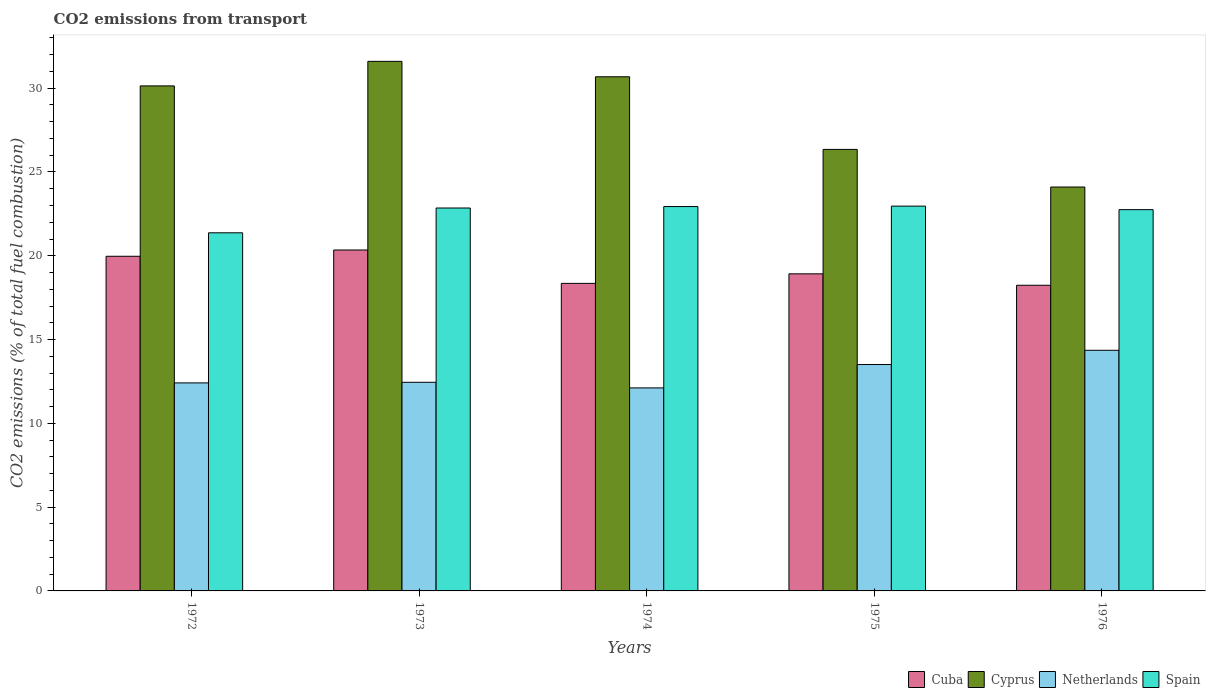How many different coloured bars are there?
Your answer should be compact. 4. Are the number of bars per tick equal to the number of legend labels?
Keep it short and to the point. Yes. How many bars are there on the 4th tick from the left?
Give a very brief answer. 4. How many bars are there on the 2nd tick from the right?
Your response must be concise. 4. What is the label of the 1st group of bars from the left?
Your answer should be very brief. 1972. In how many cases, is the number of bars for a given year not equal to the number of legend labels?
Provide a short and direct response. 0. What is the total CO2 emitted in Netherlands in 1976?
Your answer should be very brief. 14.36. Across all years, what is the maximum total CO2 emitted in Spain?
Make the answer very short. 22.96. Across all years, what is the minimum total CO2 emitted in Cuba?
Ensure brevity in your answer.  18.24. In which year was the total CO2 emitted in Spain maximum?
Provide a succinct answer. 1975. In which year was the total CO2 emitted in Spain minimum?
Your response must be concise. 1972. What is the total total CO2 emitted in Netherlands in the graph?
Ensure brevity in your answer.  64.85. What is the difference between the total CO2 emitted in Netherlands in 1972 and that in 1973?
Keep it short and to the point. -0.04. What is the difference between the total CO2 emitted in Cuba in 1973 and the total CO2 emitted in Spain in 1974?
Ensure brevity in your answer.  -2.59. What is the average total CO2 emitted in Cyprus per year?
Give a very brief answer. 28.57. In the year 1975, what is the difference between the total CO2 emitted in Cuba and total CO2 emitted in Cyprus?
Give a very brief answer. -7.42. What is the ratio of the total CO2 emitted in Netherlands in 1973 to that in 1974?
Offer a very short reply. 1.03. Is the difference between the total CO2 emitted in Cuba in 1973 and 1975 greater than the difference between the total CO2 emitted in Cyprus in 1973 and 1975?
Provide a short and direct response. No. What is the difference between the highest and the second highest total CO2 emitted in Netherlands?
Ensure brevity in your answer.  0.85. What is the difference between the highest and the lowest total CO2 emitted in Cyprus?
Make the answer very short. 7.5. Is it the case that in every year, the sum of the total CO2 emitted in Spain and total CO2 emitted in Cuba is greater than the sum of total CO2 emitted in Cyprus and total CO2 emitted in Netherlands?
Your answer should be very brief. No. What does the 1st bar from the right in 1975 represents?
Provide a succinct answer. Spain. Are all the bars in the graph horizontal?
Give a very brief answer. No. Does the graph contain any zero values?
Keep it short and to the point. No. Where does the legend appear in the graph?
Provide a succinct answer. Bottom right. What is the title of the graph?
Give a very brief answer. CO2 emissions from transport. Does "Philippines" appear as one of the legend labels in the graph?
Your response must be concise. No. What is the label or title of the X-axis?
Offer a very short reply. Years. What is the label or title of the Y-axis?
Offer a very short reply. CO2 emissions (% of total fuel combustion). What is the CO2 emissions (% of total fuel combustion) in Cuba in 1972?
Your response must be concise. 19.97. What is the CO2 emissions (% of total fuel combustion) of Cyprus in 1972?
Give a very brief answer. 30.14. What is the CO2 emissions (% of total fuel combustion) in Netherlands in 1972?
Provide a short and direct response. 12.41. What is the CO2 emissions (% of total fuel combustion) of Spain in 1972?
Offer a very short reply. 21.37. What is the CO2 emissions (% of total fuel combustion) in Cuba in 1973?
Offer a terse response. 20.34. What is the CO2 emissions (% of total fuel combustion) of Cyprus in 1973?
Keep it short and to the point. 31.6. What is the CO2 emissions (% of total fuel combustion) of Netherlands in 1973?
Offer a very short reply. 12.45. What is the CO2 emissions (% of total fuel combustion) of Spain in 1973?
Offer a very short reply. 22.85. What is the CO2 emissions (% of total fuel combustion) in Cuba in 1974?
Offer a terse response. 18.35. What is the CO2 emissions (% of total fuel combustion) in Cyprus in 1974?
Ensure brevity in your answer.  30.68. What is the CO2 emissions (% of total fuel combustion) of Netherlands in 1974?
Provide a succinct answer. 12.12. What is the CO2 emissions (% of total fuel combustion) of Spain in 1974?
Offer a very short reply. 22.94. What is the CO2 emissions (% of total fuel combustion) of Cuba in 1975?
Offer a terse response. 18.92. What is the CO2 emissions (% of total fuel combustion) of Cyprus in 1975?
Offer a terse response. 26.35. What is the CO2 emissions (% of total fuel combustion) of Netherlands in 1975?
Keep it short and to the point. 13.51. What is the CO2 emissions (% of total fuel combustion) in Spain in 1975?
Ensure brevity in your answer.  22.96. What is the CO2 emissions (% of total fuel combustion) in Cuba in 1976?
Provide a short and direct response. 18.24. What is the CO2 emissions (% of total fuel combustion) of Cyprus in 1976?
Provide a succinct answer. 24.1. What is the CO2 emissions (% of total fuel combustion) of Netherlands in 1976?
Give a very brief answer. 14.36. What is the CO2 emissions (% of total fuel combustion) in Spain in 1976?
Offer a terse response. 22.75. Across all years, what is the maximum CO2 emissions (% of total fuel combustion) in Cuba?
Give a very brief answer. 20.34. Across all years, what is the maximum CO2 emissions (% of total fuel combustion) in Cyprus?
Offer a very short reply. 31.6. Across all years, what is the maximum CO2 emissions (% of total fuel combustion) of Netherlands?
Make the answer very short. 14.36. Across all years, what is the maximum CO2 emissions (% of total fuel combustion) in Spain?
Ensure brevity in your answer.  22.96. Across all years, what is the minimum CO2 emissions (% of total fuel combustion) in Cuba?
Give a very brief answer. 18.24. Across all years, what is the minimum CO2 emissions (% of total fuel combustion) of Cyprus?
Offer a very short reply. 24.1. Across all years, what is the minimum CO2 emissions (% of total fuel combustion) in Netherlands?
Make the answer very short. 12.12. Across all years, what is the minimum CO2 emissions (% of total fuel combustion) of Spain?
Your answer should be very brief. 21.37. What is the total CO2 emissions (% of total fuel combustion) in Cuba in the graph?
Give a very brief answer. 95.83. What is the total CO2 emissions (% of total fuel combustion) in Cyprus in the graph?
Offer a terse response. 142.87. What is the total CO2 emissions (% of total fuel combustion) of Netherlands in the graph?
Provide a short and direct response. 64.85. What is the total CO2 emissions (% of total fuel combustion) in Spain in the graph?
Your answer should be very brief. 112.87. What is the difference between the CO2 emissions (% of total fuel combustion) of Cuba in 1972 and that in 1973?
Make the answer very short. -0.37. What is the difference between the CO2 emissions (% of total fuel combustion) of Cyprus in 1972 and that in 1973?
Offer a very short reply. -1.46. What is the difference between the CO2 emissions (% of total fuel combustion) in Netherlands in 1972 and that in 1973?
Provide a short and direct response. -0.04. What is the difference between the CO2 emissions (% of total fuel combustion) in Spain in 1972 and that in 1973?
Give a very brief answer. -1.48. What is the difference between the CO2 emissions (% of total fuel combustion) in Cuba in 1972 and that in 1974?
Provide a succinct answer. 1.62. What is the difference between the CO2 emissions (% of total fuel combustion) of Cyprus in 1972 and that in 1974?
Give a very brief answer. -0.54. What is the difference between the CO2 emissions (% of total fuel combustion) in Netherlands in 1972 and that in 1974?
Provide a succinct answer. 0.3. What is the difference between the CO2 emissions (% of total fuel combustion) in Spain in 1972 and that in 1974?
Your response must be concise. -1.57. What is the difference between the CO2 emissions (% of total fuel combustion) of Cuba in 1972 and that in 1975?
Your answer should be compact. 1.05. What is the difference between the CO2 emissions (% of total fuel combustion) in Cyprus in 1972 and that in 1975?
Keep it short and to the point. 3.79. What is the difference between the CO2 emissions (% of total fuel combustion) in Netherlands in 1972 and that in 1975?
Your answer should be compact. -1.1. What is the difference between the CO2 emissions (% of total fuel combustion) of Spain in 1972 and that in 1975?
Offer a very short reply. -1.59. What is the difference between the CO2 emissions (% of total fuel combustion) of Cuba in 1972 and that in 1976?
Ensure brevity in your answer.  1.73. What is the difference between the CO2 emissions (% of total fuel combustion) in Cyprus in 1972 and that in 1976?
Your answer should be very brief. 6.03. What is the difference between the CO2 emissions (% of total fuel combustion) in Netherlands in 1972 and that in 1976?
Your answer should be compact. -1.95. What is the difference between the CO2 emissions (% of total fuel combustion) of Spain in 1972 and that in 1976?
Make the answer very short. -1.38. What is the difference between the CO2 emissions (% of total fuel combustion) of Cuba in 1973 and that in 1974?
Your answer should be compact. 1.99. What is the difference between the CO2 emissions (% of total fuel combustion) in Cyprus in 1973 and that in 1974?
Offer a terse response. 0.92. What is the difference between the CO2 emissions (% of total fuel combustion) in Netherlands in 1973 and that in 1974?
Give a very brief answer. 0.33. What is the difference between the CO2 emissions (% of total fuel combustion) of Spain in 1973 and that in 1974?
Keep it short and to the point. -0.09. What is the difference between the CO2 emissions (% of total fuel combustion) of Cuba in 1973 and that in 1975?
Make the answer very short. 1.42. What is the difference between the CO2 emissions (% of total fuel combustion) in Cyprus in 1973 and that in 1975?
Offer a terse response. 5.25. What is the difference between the CO2 emissions (% of total fuel combustion) in Netherlands in 1973 and that in 1975?
Offer a terse response. -1.06. What is the difference between the CO2 emissions (% of total fuel combustion) of Spain in 1973 and that in 1975?
Your response must be concise. -0.11. What is the difference between the CO2 emissions (% of total fuel combustion) of Cuba in 1973 and that in 1976?
Offer a terse response. 2.1. What is the difference between the CO2 emissions (% of total fuel combustion) in Cyprus in 1973 and that in 1976?
Offer a very short reply. 7.5. What is the difference between the CO2 emissions (% of total fuel combustion) in Netherlands in 1973 and that in 1976?
Offer a terse response. -1.91. What is the difference between the CO2 emissions (% of total fuel combustion) in Spain in 1973 and that in 1976?
Ensure brevity in your answer.  0.1. What is the difference between the CO2 emissions (% of total fuel combustion) of Cuba in 1974 and that in 1975?
Keep it short and to the point. -0.57. What is the difference between the CO2 emissions (% of total fuel combustion) of Cyprus in 1974 and that in 1975?
Ensure brevity in your answer.  4.33. What is the difference between the CO2 emissions (% of total fuel combustion) of Netherlands in 1974 and that in 1975?
Your answer should be compact. -1.4. What is the difference between the CO2 emissions (% of total fuel combustion) in Spain in 1974 and that in 1975?
Your response must be concise. -0.03. What is the difference between the CO2 emissions (% of total fuel combustion) in Cuba in 1974 and that in 1976?
Provide a short and direct response. 0.11. What is the difference between the CO2 emissions (% of total fuel combustion) of Cyprus in 1974 and that in 1976?
Offer a terse response. 6.58. What is the difference between the CO2 emissions (% of total fuel combustion) in Netherlands in 1974 and that in 1976?
Your answer should be very brief. -2.24. What is the difference between the CO2 emissions (% of total fuel combustion) of Spain in 1974 and that in 1976?
Offer a very short reply. 0.18. What is the difference between the CO2 emissions (% of total fuel combustion) of Cuba in 1975 and that in 1976?
Offer a terse response. 0.68. What is the difference between the CO2 emissions (% of total fuel combustion) in Cyprus in 1975 and that in 1976?
Offer a terse response. 2.24. What is the difference between the CO2 emissions (% of total fuel combustion) in Netherlands in 1975 and that in 1976?
Make the answer very short. -0.85. What is the difference between the CO2 emissions (% of total fuel combustion) of Spain in 1975 and that in 1976?
Keep it short and to the point. 0.21. What is the difference between the CO2 emissions (% of total fuel combustion) of Cuba in 1972 and the CO2 emissions (% of total fuel combustion) of Cyprus in 1973?
Make the answer very short. -11.63. What is the difference between the CO2 emissions (% of total fuel combustion) of Cuba in 1972 and the CO2 emissions (% of total fuel combustion) of Netherlands in 1973?
Provide a succinct answer. 7.52. What is the difference between the CO2 emissions (% of total fuel combustion) of Cuba in 1972 and the CO2 emissions (% of total fuel combustion) of Spain in 1973?
Provide a short and direct response. -2.88. What is the difference between the CO2 emissions (% of total fuel combustion) in Cyprus in 1972 and the CO2 emissions (% of total fuel combustion) in Netherlands in 1973?
Your response must be concise. 17.69. What is the difference between the CO2 emissions (% of total fuel combustion) of Cyprus in 1972 and the CO2 emissions (% of total fuel combustion) of Spain in 1973?
Offer a terse response. 7.29. What is the difference between the CO2 emissions (% of total fuel combustion) of Netherlands in 1972 and the CO2 emissions (% of total fuel combustion) of Spain in 1973?
Offer a very short reply. -10.44. What is the difference between the CO2 emissions (% of total fuel combustion) in Cuba in 1972 and the CO2 emissions (% of total fuel combustion) in Cyprus in 1974?
Provide a succinct answer. -10.71. What is the difference between the CO2 emissions (% of total fuel combustion) in Cuba in 1972 and the CO2 emissions (% of total fuel combustion) in Netherlands in 1974?
Ensure brevity in your answer.  7.85. What is the difference between the CO2 emissions (% of total fuel combustion) in Cuba in 1972 and the CO2 emissions (% of total fuel combustion) in Spain in 1974?
Make the answer very short. -2.97. What is the difference between the CO2 emissions (% of total fuel combustion) in Cyprus in 1972 and the CO2 emissions (% of total fuel combustion) in Netherlands in 1974?
Your answer should be very brief. 18.02. What is the difference between the CO2 emissions (% of total fuel combustion) in Cyprus in 1972 and the CO2 emissions (% of total fuel combustion) in Spain in 1974?
Provide a short and direct response. 7.2. What is the difference between the CO2 emissions (% of total fuel combustion) in Netherlands in 1972 and the CO2 emissions (% of total fuel combustion) in Spain in 1974?
Your answer should be very brief. -10.52. What is the difference between the CO2 emissions (% of total fuel combustion) in Cuba in 1972 and the CO2 emissions (% of total fuel combustion) in Cyprus in 1975?
Your response must be concise. -6.38. What is the difference between the CO2 emissions (% of total fuel combustion) in Cuba in 1972 and the CO2 emissions (% of total fuel combustion) in Netherlands in 1975?
Your answer should be compact. 6.46. What is the difference between the CO2 emissions (% of total fuel combustion) in Cuba in 1972 and the CO2 emissions (% of total fuel combustion) in Spain in 1975?
Your response must be concise. -2.99. What is the difference between the CO2 emissions (% of total fuel combustion) of Cyprus in 1972 and the CO2 emissions (% of total fuel combustion) of Netherlands in 1975?
Offer a very short reply. 16.63. What is the difference between the CO2 emissions (% of total fuel combustion) of Cyprus in 1972 and the CO2 emissions (% of total fuel combustion) of Spain in 1975?
Offer a very short reply. 7.17. What is the difference between the CO2 emissions (% of total fuel combustion) in Netherlands in 1972 and the CO2 emissions (% of total fuel combustion) in Spain in 1975?
Ensure brevity in your answer.  -10.55. What is the difference between the CO2 emissions (% of total fuel combustion) of Cuba in 1972 and the CO2 emissions (% of total fuel combustion) of Cyprus in 1976?
Your answer should be compact. -4.13. What is the difference between the CO2 emissions (% of total fuel combustion) of Cuba in 1972 and the CO2 emissions (% of total fuel combustion) of Netherlands in 1976?
Provide a succinct answer. 5.61. What is the difference between the CO2 emissions (% of total fuel combustion) in Cuba in 1972 and the CO2 emissions (% of total fuel combustion) in Spain in 1976?
Give a very brief answer. -2.78. What is the difference between the CO2 emissions (% of total fuel combustion) of Cyprus in 1972 and the CO2 emissions (% of total fuel combustion) of Netherlands in 1976?
Provide a short and direct response. 15.78. What is the difference between the CO2 emissions (% of total fuel combustion) in Cyprus in 1972 and the CO2 emissions (% of total fuel combustion) in Spain in 1976?
Your response must be concise. 7.38. What is the difference between the CO2 emissions (% of total fuel combustion) in Netherlands in 1972 and the CO2 emissions (% of total fuel combustion) in Spain in 1976?
Ensure brevity in your answer.  -10.34. What is the difference between the CO2 emissions (% of total fuel combustion) in Cuba in 1973 and the CO2 emissions (% of total fuel combustion) in Cyprus in 1974?
Your answer should be very brief. -10.34. What is the difference between the CO2 emissions (% of total fuel combustion) in Cuba in 1973 and the CO2 emissions (% of total fuel combustion) in Netherlands in 1974?
Your answer should be compact. 8.23. What is the difference between the CO2 emissions (% of total fuel combustion) of Cuba in 1973 and the CO2 emissions (% of total fuel combustion) of Spain in 1974?
Provide a succinct answer. -2.59. What is the difference between the CO2 emissions (% of total fuel combustion) of Cyprus in 1973 and the CO2 emissions (% of total fuel combustion) of Netherlands in 1974?
Give a very brief answer. 19.49. What is the difference between the CO2 emissions (% of total fuel combustion) in Cyprus in 1973 and the CO2 emissions (% of total fuel combustion) in Spain in 1974?
Your response must be concise. 8.67. What is the difference between the CO2 emissions (% of total fuel combustion) in Netherlands in 1973 and the CO2 emissions (% of total fuel combustion) in Spain in 1974?
Offer a very short reply. -10.49. What is the difference between the CO2 emissions (% of total fuel combustion) of Cuba in 1973 and the CO2 emissions (% of total fuel combustion) of Cyprus in 1975?
Provide a short and direct response. -6. What is the difference between the CO2 emissions (% of total fuel combustion) of Cuba in 1973 and the CO2 emissions (% of total fuel combustion) of Netherlands in 1975?
Keep it short and to the point. 6.83. What is the difference between the CO2 emissions (% of total fuel combustion) in Cuba in 1973 and the CO2 emissions (% of total fuel combustion) in Spain in 1975?
Your answer should be compact. -2.62. What is the difference between the CO2 emissions (% of total fuel combustion) in Cyprus in 1973 and the CO2 emissions (% of total fuel combustion) in Netherlands in 1975?
Make the answer very short. 18.09. What is the difference between the CO2 emissions (% of total fuel combustion) of Cyprus in 1973 and the CO2 emissions (% of total fuel combustion) of Spain in 1975?
Your answer should be compact. 8.64. What is the difference between the CO2 emissions (% of total fuel combustion) of Netherlands in 1973 and the CO2 emissions (% of total fuel combustion) of Spain in 1975?
Make the answer very short. -10.51. What is the difference between the CO2 emissions (% of total fuel combustion) of Cuba in 1973 and the CO2 emissions (% of total fuel combustion) of Cyprus in 1976?
Your answer should be compact. -3.76. What is the difference between the CO2 emissions (% of total fuel combustion) in Cuba in 1973 and the CO2 emissions (% of total fuel combustion) in Netherlands in 1976?
Your answer should be compact. 5.99. What is the difference between the CO2 emissions (% of total fuel combustion) in Cuba in 1973 and the CO2 emissions (% of total fuel combustion) in Spain in 1976?
Your answer should be very brief. -2.41. What is the difference between the CO2 emissions (% of total fuel combustion) in Cyprus in 1973 and the CO2 emissions (% of total fuel combustion) in Netherlands in 1976?
Give a very brief answer. 17.24. What is the difference between the CO2 emissions (% of total fuel combustion) of Cyprus in 1973 and the CO2 emissions (% of total fuel combustion) of Spain in 1976?
Ensure brevity in your answer.  8.85. What is the difference between the CO2 emissions (% of total fuel combustion) in Netherlands in 1973 and the CO2 emissions (% of total fuel combustion) in Spain in 1976?
Your answer should be very brief. -10.3. What is the difference between the CO2 emissions (% of total fuel combustion) in Cuba in 1974 and the CO2 emissions (% of total fuel combustion) in Cyprus in 1975?
Provide a succinct answer. -7.99. What is the difference between the CO2 emissions (% of total fuel combustion) in Cuba in 1974 and the CO2 emissions (% of total fuel combustion) in Netherlands in 1975?
Ensure brevity in your answer.  4.84. What is the difference between the CO2 emissions (% of total fuel combustion) in Cuba in 1974 and the CO2 emissions (% of total fuel combustion) in Spain in 1975?
Provide a succinct answer. -4.61. What is the difference between the CO2 emissions (% of total fuel combustion) in Cyprus in 1974 and the CO2 emissions (% of total fuel combustion) in Netherlands in 1975?
Your answer should be compact. 17.17. What is the difference between the CO2 emissions (% of total fuel combustion) of Cyprus in 1974 and the CO2 emissions (% of total fuel combustion) of Spain in 1975?
Make the answer very short. 7.72. What is the difference between the CO2 emissions (% of total fuel combustion) of Netherlands in 1974 and the CO2 emissions (% of total fuel combustion) of Spain in 1975?
Offer a terse response. -10.85. What is the difference between the CO2 emissions (% of total fuel combustion) of Cuba in 1974 and the CO2 emissions (% of total fuel combustion) of Cyprus in 1976?
Your answer should be very brief. -5.75. What is the difference between the CO2 emissions (% of total fuel combustion) of Cuba in 1974 and the CO2 emissions (% of total fuel combustion) of Netherlands in 1976?
Ensure brevity in your answer.  3.99. What is the difference between the CO2 emissions (% of total fuel combustion) of Cuba in 1974 and the CO2 emissions (% of total fuel combustion) of Spain in 1976?
Provide a succinct answer. -4.4. What is the difference between the CO2 emissions (% of total fuel combustion) in Cyprus in 1974 and the CO2 emissions (% of total fuel combustion) in Netherlands in 1976?
Provide a short and direct response. 16.32. What is the difference between the CO2 emissions (% of total fuel combustion) of Cyprus in 1974 and the CO2 emissions (% of total fuel combustion) of Spain in 1976?
Offer a very short reply. 7.93. What is the difference between the CO2 emissions (% of total fuel combustion) of Netherlands in 1974 and the CO2 emissions (% of total fuel combustion) of Spain in 1976?
Offer a terse response. -10.64. What is the difference between the CO2 emissions (% of total fuel combustion) in Cuba in 1975 and the CO2 emissions (% of total fuel combustion) in Cyprus in 1976?
Make the answer very short. -5.18. What is the difference between the CO2 emissions (% of total fuel combustion) in Cuba in 1975 and the CO2 emissions (% of total fuel combustion) in Netherlands in 1976?
Give a very brief answer. 4.56. What is the difference between the CO2 emissions (% of total fuel combustion) of Cuba in 1975 and the CO2 emissions (% of total fuel combustion) of Spain in 1976?
Offer a terse response. -3.83. What is the difference between the CO2 emissions (% of total fuel combustion) of Cyprus in 1975 and the CO2 emissions (% of total fuel combustion) of Netherlands in 1976?
Offer a very short reply. 11.99. What is the difference between the CO2 emissions (% of total fuel combustion) of Cyprus in 1975 and the CO2 emissions (% of total fuel combustion) of Spain in 1976?
Provide a short and direct response. 3.6. What is the difference between the CO2 emissions (% of total fuel combustion) in Netherlands in 1975 and the CO2 emissions (% of total fuel combustion) in Spain in 1976?
Keep it short and to the point. -9.24. What is the average CO2 emissions (% of total fuel combustion) in Cuba per year?
Your answer should be very brief. 19.17. What is the average CO2 emissions (% of total fuel combustion) in Cyprus per year?
Offer a very short reply. 28.57. What is the average CO2 emissions (% of total fuel combustion) in Netherlands per year?
Your response must be concise. 12.97. What is the average CO2 emissions (% of total fuel combustion) of Spain per year?
Offer a terse response. 22.57. In the year 1972, what is the difference between the CO2 emissions (% of total fuel combustion) in Cuba and CO2 emissions (% of total fuel combustion) in Cyprus?
Offer a terse response. -10.17. In the year 1972, what is the difference between the CO2 emissions (% of total fuel combustion) of Cuba and CO2 emissions (% of total fuel combustion) of Netherlands?
Provide a succinct answer. 7.56. In the year 1972, what is the difference between the CO2 emissions (% of total fuel combustion) in Cuba and CO2 emissions (% of total fuel combustion) in Spain?
Give a very brief answer. -1.4. In the year 1972, what is the difference between the CO2 emissions (% of total fuel combustion) in Cyprus and CO2 emissions (% of total fuel combustion) in Netherlands?
Keep it short and to the point. 17.72. In the year 1972, what is the difference between the CO2 emissions (% of total fuel combustion) in Cyprus and CO2 emissions (% of total fuel combustion) in Spain?
Keep it short and to the point. 8.77. In the year 1972, what is the difference between the CO2 emissions (% of total fuel combustion) of Netherlands and CO2 emissions (% of total fuel combustion) of Spain?
Provide a succinct answer. -8.96. In the year 1973, what is the difference between the CO2 emissions (% of total fuel combustion) of Cuba and CO2 emissions (% of total fuel combustion) of Cyprus?
Your answer should be very brief. -11.26. In the year 1973, what is the difference between the CO2 emissions (% of total fuel combustion) of Cuba and CO2 emissions (% of total fuel combustion) of Netherlands?
Offer a terse response. 7.89. In the year 1973, what is the difference between the CO2 emissions (% of total fuel combustion) of Cuba and CO2 emissions (% of total fuel combustion) of Spain?
Provide a succinct answer. -2.51. In the year 1973, what is the difference between the CO2 emissions (% of total fuel combustion) in Cyprus and CO2 emissions (% of total fuel combustion) in Netherlands?
Your answer should be very brief. 19.15. In the year 1973, what is the difference between the CO2 emissions (% of total fuel combustion) in Cyprus and CO2 emissions (% of total fuel combustion) in Spain?
Offer a terse response. 8.75. In the year 1973, what is the difference between the CO2 emissions (% of total fuel combustion) of Netherlands and CO2 emissions (% of total fuel combustion) of Spain?
Provide a short and direct response. -10.4. In the year 1974, what is the difference between the CO2 emissions (% of total fuel combustion) in Cuba and CO2 emissions (% of total fuel combustion) in Cyprus?
Your answer should be very brief. -12.33. In the year 1974, what is the difference between the CO2 emissions (% of total fuel combustion) in Cuba and CO2 emissions (% of total fuel combustion) in Netherlands?
Make the answer very short. 6.24. In the year 1974, what is the difference between the CO2 emissions (% of total fuel combustion) of Cuba and CO2 emissions (% of total fuel combustion) of Spain?
Your answer should be very brief. -4.58. In the year 1974, what is the difference between the CO2 emissions (% of total fuel combustion) of Cyprus and CO2 emissions (% of total fuel combustion) of Netherlands?
Provide a succinct answer. 18.57. In the year 1974, what is the difference between the CO2 emissions (% of total fuel combustion) in Cyprus and CO2 emissions (% of total fuel combustion) in Spain?
Keep it short and to the point. 7.75. In the year 1974, what is the difference between the CO2 emissions (% of total fuel combustion) of Netherlands and CO2 emissions (% of total fuel combustion) of Spain?
Your response must be concise. -10.82. In the year 1975, what is the difference between the CO2 emissions (% of total fuel combustion) in Cuba and CO2 emissions (% of total fuel combustion) in Cyprus?
Your answer should be compact. -7.42. In the year 1975, what is the difference between the CO2 emissions (% of total fuel combustion) in Cuba and CO2 emissions (% of total fuel combustion) in Netherlands?
Keep it short and to the point. 5.41. In the year 1975, what is the difference between the CO2 emissions (% of total fuel combustion) in Cuba and CO2 emissions (% of total fuel combustion) in Spain?
Keep it short and to the point. -4.04. In the year 1975, what is the difference between the CO2 emissions (% of total fuel combustion) of Cyprus and CO2 emissions (% of total fuel combustion) of Netherlands?
Keep it short and to the point. 12.84. In the year 1975, what is the difference between the CO2 emissions (% of total fuel combustion) in Cyprus and CO2 emissions (% of total fuel combustion) in Spain?
Keep it short and to the point. 3.38. In the year 1975, what is the difference between the CO2 emissions (% of total fuel combustion) of Netherlands and CO2 emissions (% of total fuel combustion) of Spain?
Offer a very short reply. -9.45. In the year 1976, what is the difference between the CO2 emissions (% of total fuel combustion) of Cuba and CO2 emissions (% of total fuel combustion) of Cyprus?
Your response must be concise. -5.86. In the year 1976, what is the difference between the CO2 emissions (% of total fuel combustion) of Cuba and CO2 emissions (% of total fuel combustion) of Netherlands?
Offer a terse response. 3.88. In the year 1976, what is the difference between the CO2 emissions (% of total fuel combustion) of Cuba and CO2 emissions (% of total fuel combustion) of Spain?
Your response must be concise. -4.51. In the year 1976, what is the difference between the CO2 emissions (% of total fuel combustion) in Cyprus and CO2 emissions (% of total fuel combustion) in Netherlands?
Offer a very short reply. 9.74. In the year 1976, what is the difference between the CO2 emissions (% of total fuel combustion) of Cyprus and CO2 emissions (% of total fuel combustion) of Spain?
Your answer should be very brief. 1.35. In the year 1976, what is the difference between the CO2 emissions (% of total fuel combustion) in Netherlands and CO2 emissions (% of total fuel combustion) in Spain?
Your response must be concise. -8.39. What is the ratio of the CO2 emissions (% of total fuel combustion) of Cuba in 1972 to that in 1973?
Provide a succinct answer. 0.98. What is the ratio of the CO2 emissions (% of total fuel combustion) in Cyprus in 1972 to that in 1973?
Your response must be concise. 0.95. What is the ratio of the CO2 emissions (% of total fuel combustion) of Spain in 1972 to that in 1973?
Ensure brevity in your answer.  0.94. What is the ratio of the CO2 emissions (% of total fuel combustion) of Cuba in 1972 to that in 1974?
Ensure brevity in your answer.  1.09. What is the ratio of the CO2 emissions (% of total fuel combustion) in Cyprus in 1972 to that in 1974?
Keep it short and to the point. 0.98. What is the ratio of the CO2 emissions (% of total fuel combustion) of Netherlands in 1972 to that in 1974?
Make the answer very short. 1.02. What is the ratio of the CO2 emissions (% of total fuel combustion) of Spain in 1972 to that in 1974?
Your response must be concise. 0.93. What is the ratio of the CO2 emissions (% of total fuel combustion) in Cuba in 1972 to that in 1975?
Provide a short and direct response. 1.06. What is the ratio of the CO2 emissions (% of total fuel combustion) in Cyprus in 1972 to that in 1975?
Your answer should be compact. 1.14. What is the ratio of the CO2 emissions (% of total fuel combustion) in Netherlands in 1972 to that in 1975?
Make the answer very short. 0.92. What is the ratio of the CO2 emissions (% of total fuel combustion) of Spain in 1972 to that in 1975?
Provide a succinct answer. 0.93. What is the ratio of the CO2 emissions (% of total fuel combustion) in Cuba in 1972 to that in 1976?
Ensure brevity in your answer.  1.09. What is the ratio of the CO2 emissions (% of total fuel combustion) in Cyprus in 1972 to that in 1976?
Make the answer very short. 1.25. What is the ratio of the CO2 emissions (% of total fuel combustion) in Netherlands in 1972 to that in 1976?
Offer a very short reply. 0.86. What is the ratio of the CO2 emissions (% of total fuel combustion) in Spain in 1972 to that in 1976?
Provide a succinct answer. 0.94. What is the ratio of the CO2 emissions (% of total fuel combustion) of Cuba in 1973 to that in 1974?
Your answer should be compact. 1.11. What is the ratio of the CO2 emissions (% of total fuel combustion) in Cyprus in 1973 to that in 1974?
Offer a terse response. 1.03. What is the ratio of the CO2 emissions (% of total fuel combustion) of Netherlands in 1973 to that in 1974?
Offer a very short reply. 1.03. What is the ratio of the CO2 emissions (% of total fuel combustion) in Spain in 1973 to that in 1974?
Your answer should be compact. 1. What is the ratio of the CO2 emissions (% of total fuel combustion) in Cuba in 1973 to that in 1975?
Your answer should be very brief. 1.08. What is the ratio of the CO2 emissions (% of total fuel combustion) of Cyprus in 1973 to that in 1975?
Provide a short and direct response. 1.2. What is the ratio of the CO2 emissions (% of total fuel combustion) of Netherlands in 1973 to that in 1975?
Offer a terse response. 0.92. What is the ratio of the CO2 emissions (% of total fuel combustion) in Cuba in 1973 to that in 1976?
Offer a terse response. 1.12. What is the ratio of the CO2 emissions (% of total fuel combustion) of Cyprus in 1973 to that in 1976?
Your answer should be very brief. 1.31. What is the ratio of the CO2 emissions (% of total fuel combustion) of Netherlands in 1973 to that in 1976?
Offer a very short reply. 0.87. What is the ratio of the CO2 emissions (% of total fuel combustion) of Spain in 1973 to that in 1976?
Offer a very short reply. 1. What is the ratio of the CO2 emissions (% of total fuel combustion) of Cuba in 1974 to that in 1975?
Ensure brevity in your answer.  0.97. What is the ratio of the CO2 emissions (% of total fuel combustion) in Cyprus in 1974 to that in 1975?
Ensure brevity in your answer.  1.16. What is the ratio of the CO2 emissions (% of total fuel combustion) in Netherlands in 1974 to that in 1975?
Your answer should be very brief. 0.9. What is the ratio of the CO2 emissions (% of total fuel combustion) in Spain in 1974 to that in 1975?
Make the answer very short. 1. What is the ratio of the CO2 emissions (% of total fuel combustion) in Cuba in 1974 to that in 1976?
Offer a terse response. 1.01. What is the ratio of the CO2 emissions (% of total fuel combustion) of Cyprus in 1974 to that in 1976?
Provide a succinct answer. 1.27. What is the ratio of the CO2 emissions (% of total fuel combustion) of Netherlands in 1974 to that in 1976?
Provide a short and direct response. 0.84. What is the ratio of the CO2 emissions (% of total fuel combustion) of Spain in 1974 to that in 1976?
Your response must be concise. 1.01. What is the ratio of the CO2 emissions (% of total fuel combustion) of Cuba in 1975 to that in 1976?
Offer a terse response. 1.04. What is the ratio of the CO2 emissions (% of total fuel combustion) of Cyprus in 1975 to that in 1976?
Your answer should be very brief. 1.09. What is the ratio of the CO2 emissions (% of total fuel combustion) in Netherlands in 1975 to that in 1976?
Your response must be concise. 0.94. What is the ratio of the CO2 emissions (% of total fuel combustion) in Spain in 1975 to that in 1976?
Give a very brief answer. 1.01. What is the difference between the highest and the second highest CO2 emissions (% of total fuel combustion) of Cuba?
Keep it short and to the point. 0.37. What is the difference between the highest and the second highest CO2 emissions (% of total fuel combustion) of Cyprus?
Provide a short and direct response. 0.92. What is the difference between the highest and the second highest CO2 emissions (% of total fuel combustion) of Netherlands?
Offer a terse response. 0.85. What is the difference between the highest and the second highest CO2 emissions (% of total fuel combustion) in Spain?
Ensure brevity in your answer.  0.03. What is the difference between the highest and the lowest CO2 emissions (% of total fuel combustion) of Cuba?
Your answer should be very brief. 2.1. What is the difference between the highest and the lowest CO2 emissions (% of total fuel combustion) in Cyprus?
Make the answer very short. 7.5. What is the difference between the highest and the lowest CO2 emissions (% of total fuel combustion) in Netherlands?
Provide a short and direct response. 2.24. What is the difference between the highest and the lowest CO2 emissions (% of total fuel combustion) in Spain?
Your response must be concise. 1.59. 